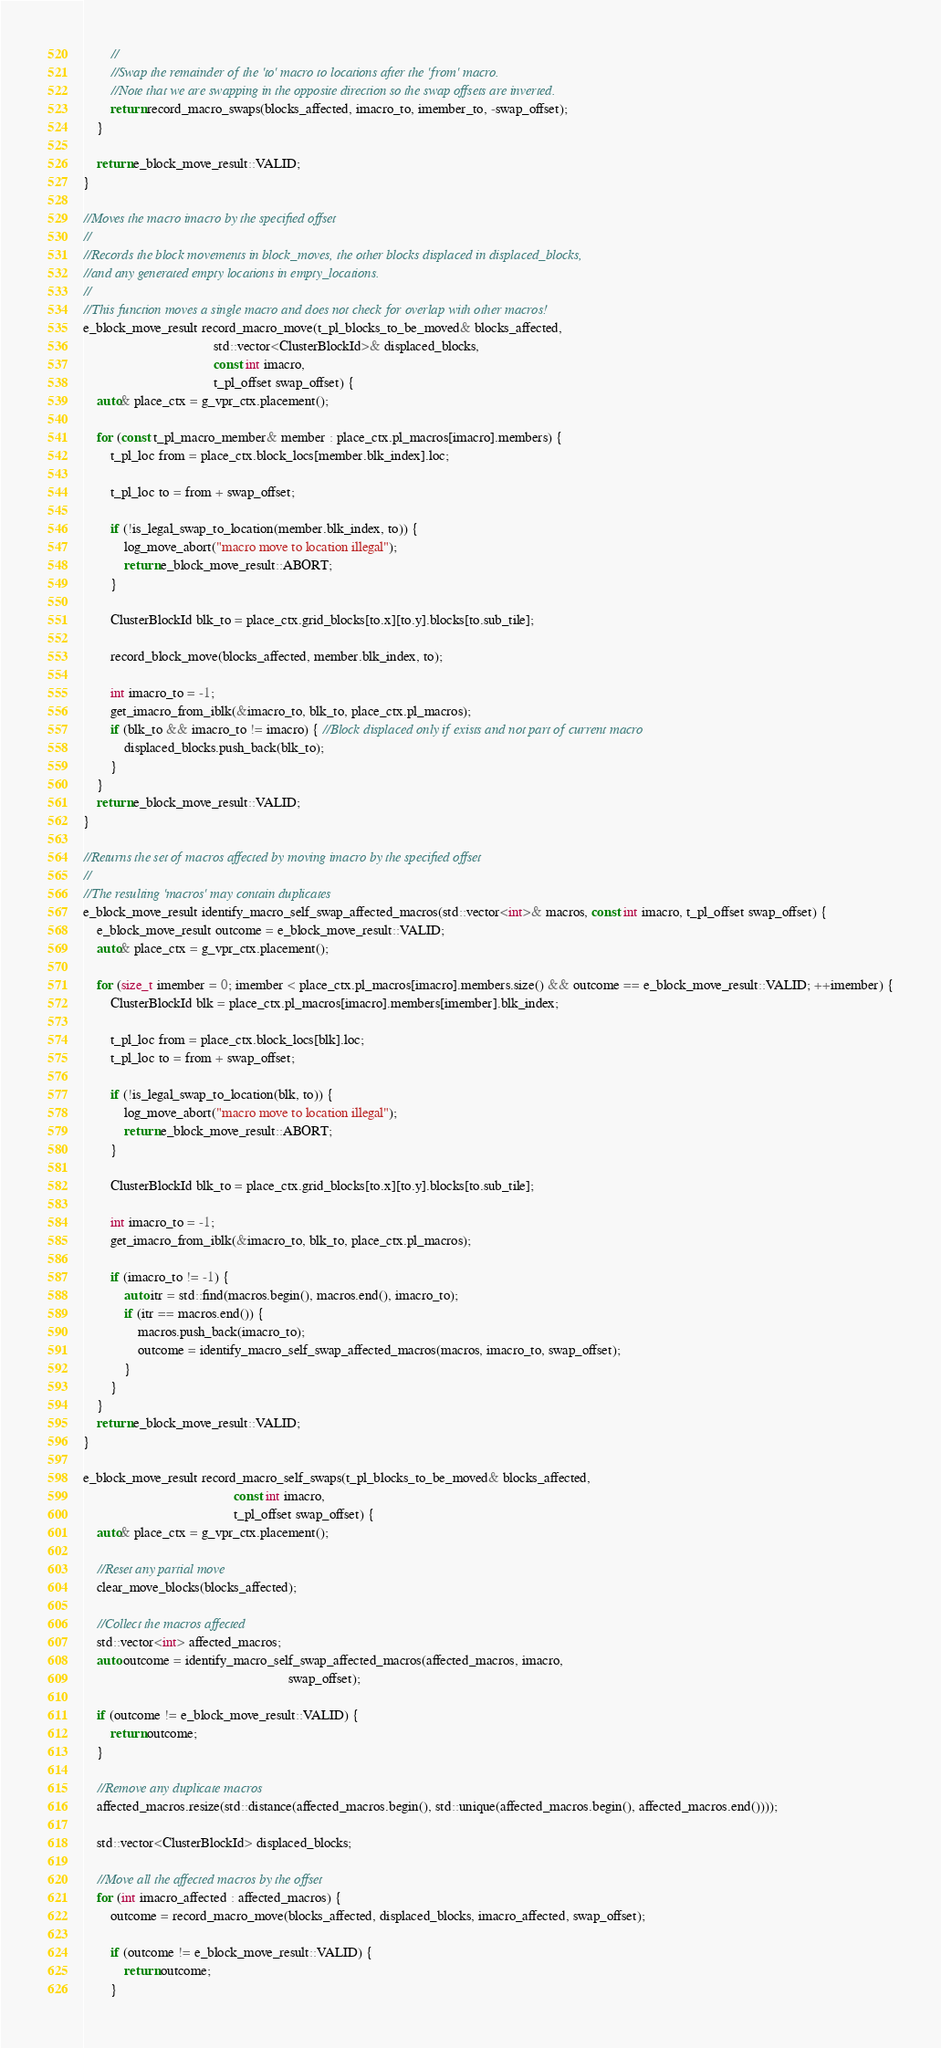<code> <loc_0><loc_0><loc_500><loc_500><_C++_>        //
        //Swap the remainder of the 'to' macro to locations after the 'from' macro.
        //Note that we are swapping in the opposite direction so the swap offsets are inverted.
        return record_macro_swaps(blocks_affected, imacro_to, imember_to, -swap_offset);
    }

    return e_block_move_result::VALID;
}

//Moves the macro imacro by the specified offset
//
//Records the block movements in block_moves, the other blocks displaced in displaced_blocks,
//and any generated empty locations in empty_locations.
//
//This function moves a single macro and does not check for overlap with other macros!
e_block_move_result record_macro_move(t_pl_blocks_to_be_moved& blocks_affected,
                                      std::vector<ClusterBlockId>& displaced_blocks,
                                      const int imacro,
                                      t_pl_offset swap_offset) {
    auto& place_ctx = g_vpr_ctx.placement();

    for (const t_pl_macro_member& member : place_ctx.pl_macros[imacro].members) {
        t_pl_loc from = place_ctx.block_locs[member.blk_index].loc;

        t_pl_loc to = from + swap_offset;

        if (!is_legal_swap_to_location(member.blk_index, to)) {
            log_move_abort("macro move to location illegal");
            return e_block_move_result::ABORT;
        }

        ClusterBlockId blk_to = place_ctx.grid_blocks[to.x][to.y].blocks[to.sub_tile];

        record_block_move(blocks_affected, member.blk_index, to);

        int imacro_to = -1;
        get_imacro_from_iblk(&imacro_to, blk_to, place_ctx.pl_macros);
        if (blk_to && imacro_to != imacro) { //Block displaced only if exists and not part of current macro
            displaced_blocks.push_back(blk_to);
        }
    }
    return e_block_move_result::VALID;
}

//Returns the set of macros affected by moving imacro by the specified offset
//
//The resulting 'macros' may contain duplicates
e_block_move_result identify_macro_self_swap_affected_macros(std::vector<int>& macros, const int imacro, t_pl_offset swap_offset) {
    e_block_move_result outcome = e_block_move_result::VALID;
    auto& place_ctx = g_vpr_ctx.placement();

    for (size_t imember = 0; imember < place_ctx.pl_macros[imacro].members.size() && outcome == e_block_move_result::VALID; ++imember) {
        ClusterBlockId blk = place_ctx.pl_macros[imacro].members[imember].blk_index;

        t_pl_loc from = place_ctx.block_locs[blk].loc;
        t_pl_loc to = from + swap_offset;

        if (!is_legal_swap_to_location(blk, to)) {
            log_move_abort("macro move to location illegal");
            return e_block_move_result::ABORT;
        }

        ClusterBlockId blk_to = place_ctx.grid_blocks[to.x][to.y].blocks[to.sub_tile];

        int imacro_to = -1;
        get_imacro_from_iblk(&imacro_to, blk_to, place_ctx.pl_macros);

        if (imacro_to != -1) {
            auto itr = std::find(macros.begin(), macros.end(), imacro_to);
            if (itr == macros.end()) {
                macros.push_back(imacro_to);
                outcome = identify_macro_self_swap_affected_macros(macros, imacro_to, swap_offset);
            }
        }
    }
    return e_block_move_result::VALID;
}

e_block_move_result record_macro_self_swaps(t_pl_blocks_to_be_moved& blocks_affected,
                                            const int imacro,
                                            t_pl_offset swap_offset) {
    auto& place_ctx = g_vpr_ctx.placement();

    //Reset any partial move
    clear_move_blocks(blocks_affected);

    //Collect the macros affected
    std::vector<int> affected_macros;
    auto outcome = identify_macro_self_swap_affected_macros(affected_macros, imacro,
                                                            swap_offset);

    if (outcome != e_block_move_result::VALID) {
        return outcome;
    }

    //Remove any duplicate macros
    affected_macros.resize(std::distance(affected_macros.begin(), std::unique(affected_macros.begin(), affected_macros.end())));

    std::vector<ClusterBlockId> displaced_blocks;

    //Move all the affected macros by the offset
    for (int imacro_affected : affected_macros) {
        outcome = record_macro_move(blocks_affected, displaced_blocks, imacro_affected, swap_offset);

        if (outcome != e_block_move_result::VALID) {
            return outcome;
        }</code> 